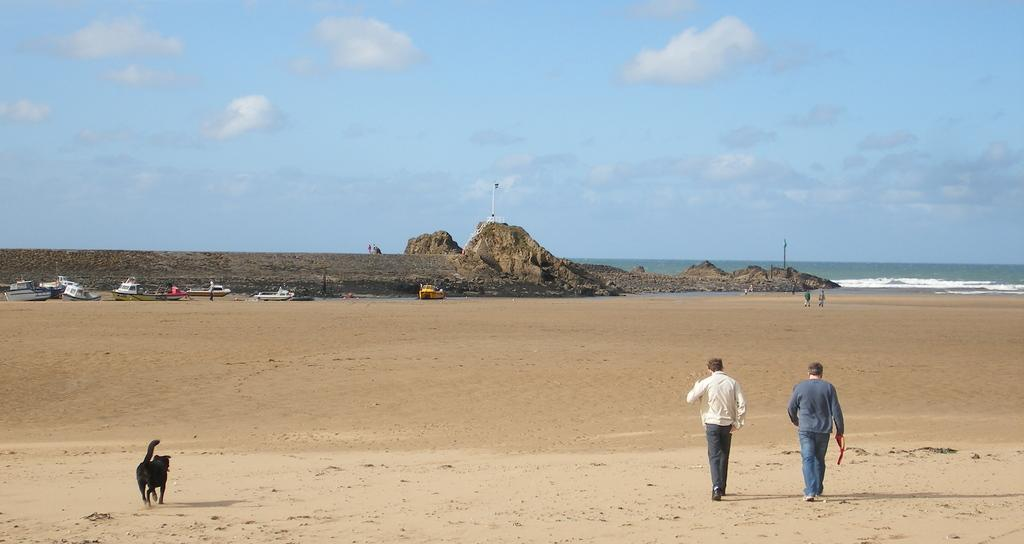What animal can be seen in the image? There is a dog in the image. What are the people in the image doing? The people in the image are walking on the sand. What can be seen in the background of the image? There are boats, a rock, water, and clouds visible in the background. Can you describe the sky in the image? The sky is visible with clouds in the background. What type of insurance does the farmer have for his nut farm in the image? There is no farmer or nut farm present in the image; it features a dog and people walking on the sand with boats, a rock, water, and clouds in the background. 